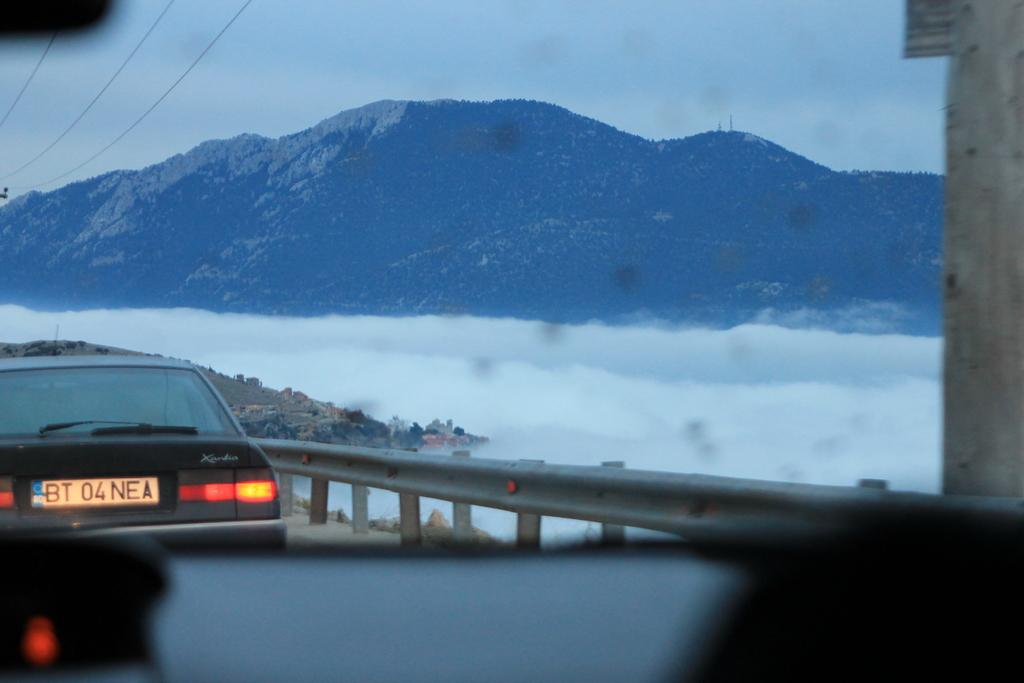What is the main subject of the image? There is a car in the image. What is located beside the car? There is a fence beside the car. What can be seen in the background of the image? There are cables and hills visible in the background of the image. What level of amusement can be seen in the image? There is no indication of amusement in the image; it features a car, a fence, cables, and hills. 